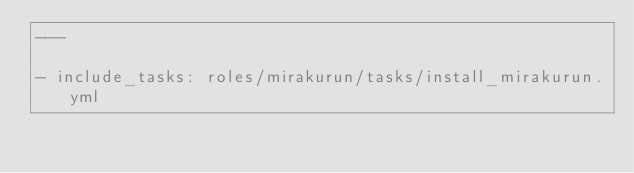<code> <loc_0><loc_0><loc_500><loc_500><_YAML_>---

- include_tasks: roles/mirakurun/tasks/install_mirakurun.yml</code> 